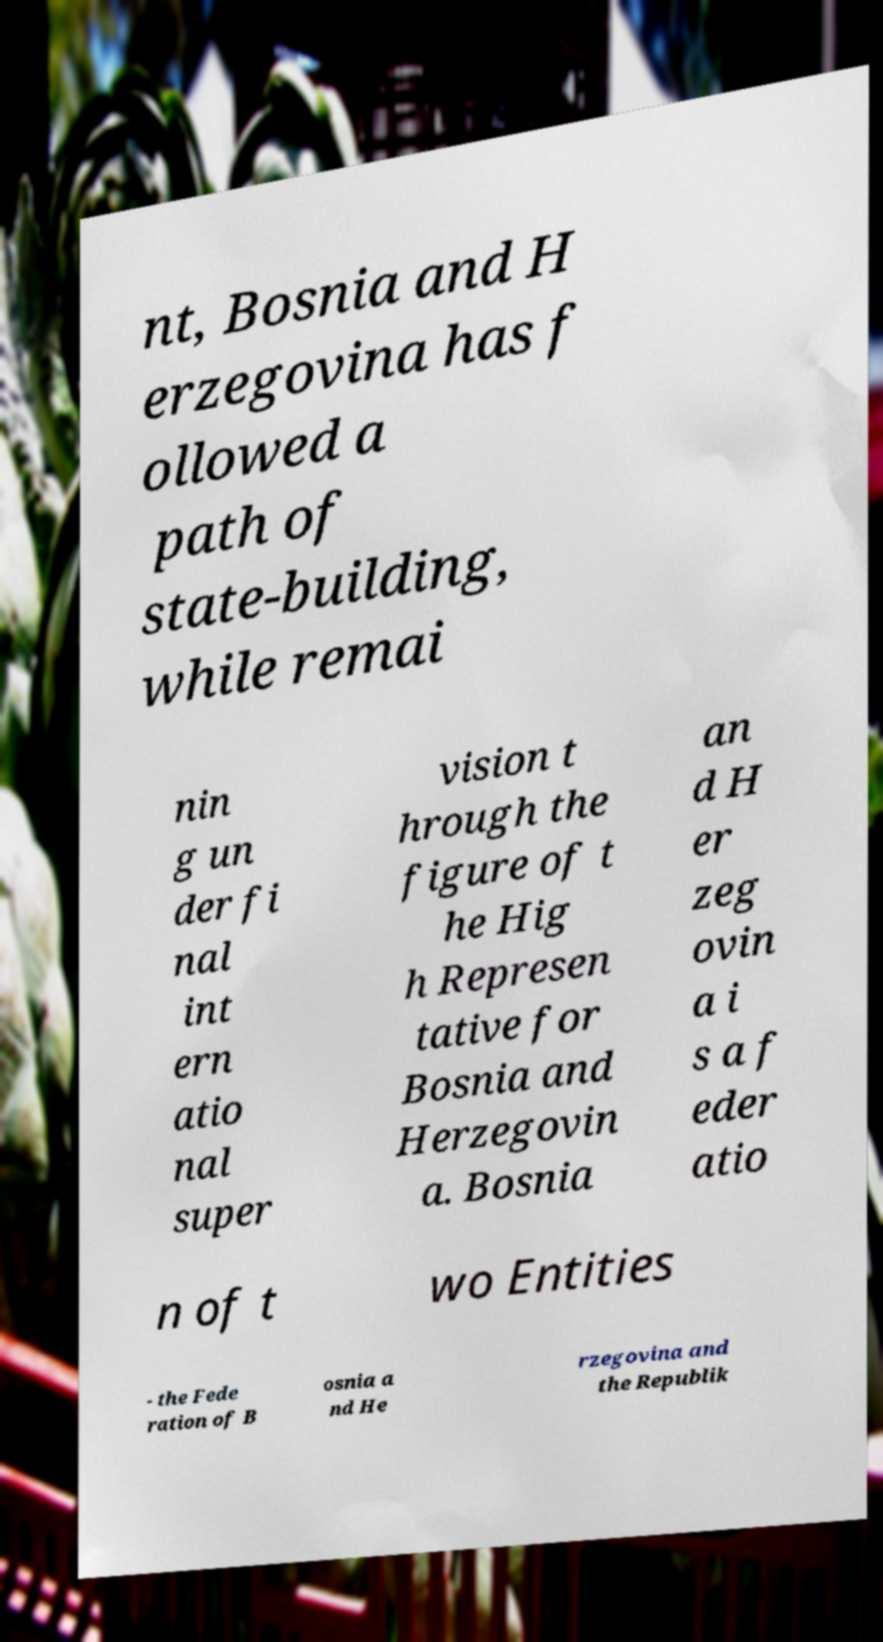There's text embedded in this image that I need extracted. Can you transcribe it verbatim? nt, Bosnia and H erzegovina has f ollowed a path of state-building, while remai nin g un der fi nal int ern atio nal super vision t hrough the figure of t he Hig h Represen tative for Bosnia and Herzegovin a. Bosnia an d H er zeg ovin a i s a f eder atio n of t wo Entities - the Fede ration of B osnia a nd He rzegovina and the Republik 